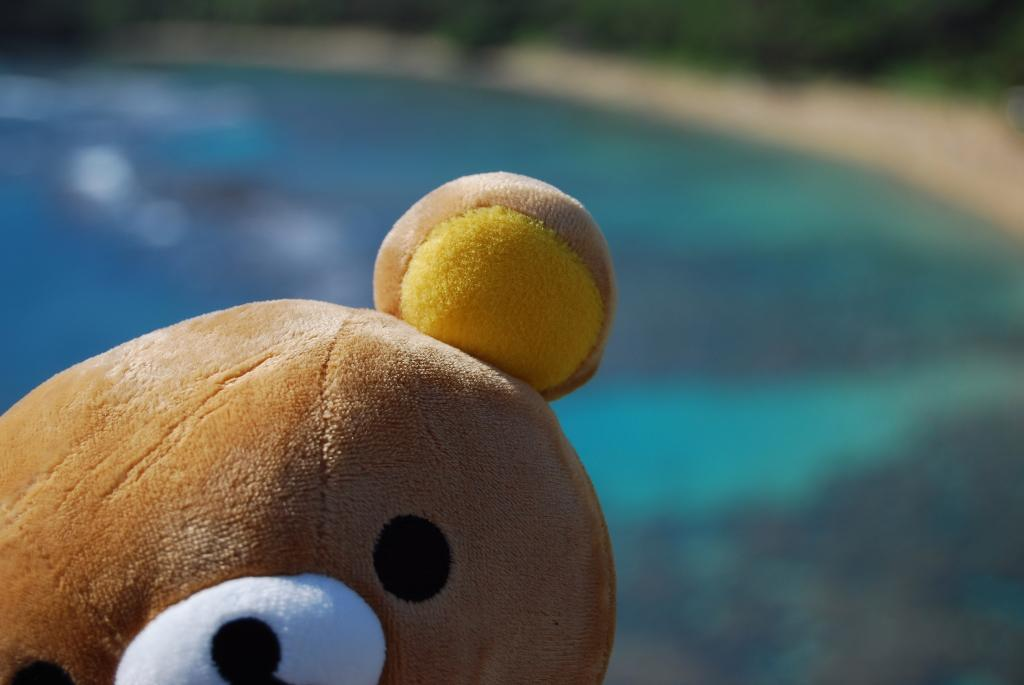What type of object can be seen in the image? There is a soft toy in the image. Is the soft toy wearing a crown in the image? There is no mention of a crown in the image, and therefore it cannot be determined if the soft toy is wearing one. 